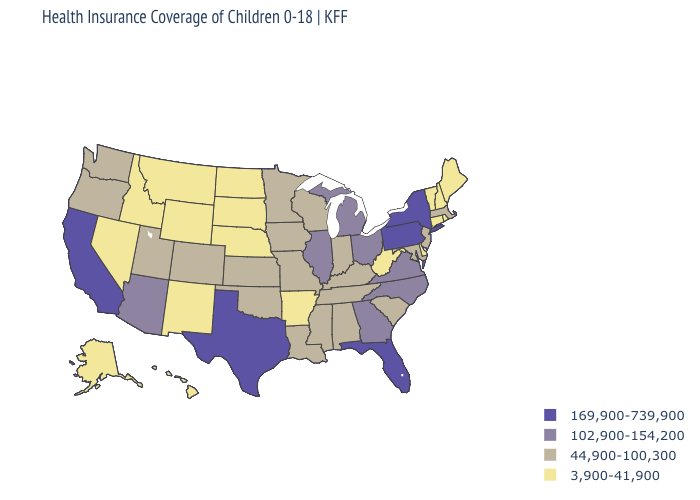What is the value of Tennessee?
Answer briefly. 44,900-100,300. What is the value of Florida?
Be succinct. 169,900-739,900. Name the states that have a value in the range 102,900-154,200?
Short answer required. Arizona, Georgia, Illinois, Michigan, North Carolina, Ohio, Virginia. What is the value of Georgia?
Concise answer only. 102,900-154,200. Does Utah have the highest value in the USA?
Concise answer only. No. What is the value of Illinois?
Quick response, please. 102,900-154,200. What is the highest value in states that border New Jersey?
Keep it brief. 169,900-739,900. How many symbols are there in the legend?
Keep it brief. 4. Does the map have missing data?
Write a very short answer. No. What is the lowest value in the USA?
Concise answer only. 3,900-41,900. What is the value of Wisconsin?
Answer briefly. 44,900-100,300. Does the first symbol in the legend represent the smallest category?
Keep it brief. No. Name the states that have a value in the range 169,900-739,900?
Concise answer only. California, Florida, New York, Pennsylvania, Texas. Name the states that have a value in the range 102,900-154,200?
Short answer required. Arizona, Georgia, Illinois, Michigan, North Carolina, Ohio, Virginia. What is the lowest value in the USA?
Answer briefly. 3,900-41,900. 